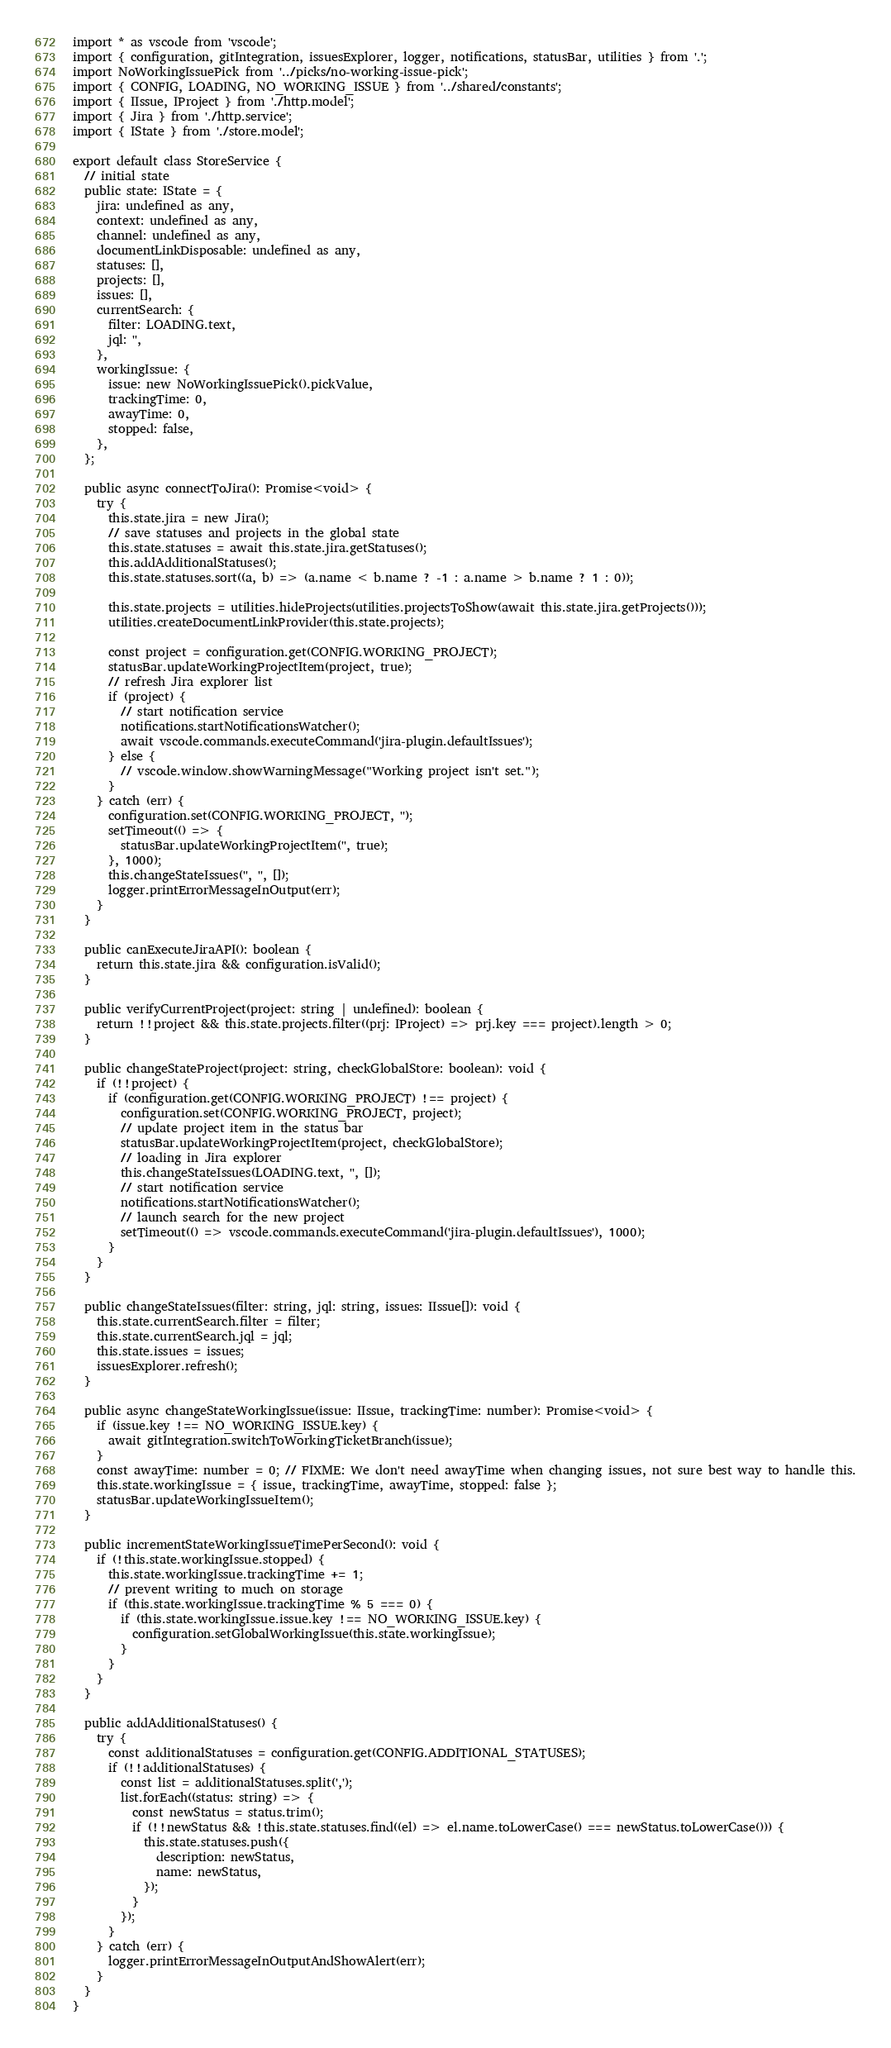Convert code to text. <code><loc_0><loc_0><loc_500><loc_500><_TypeScript_>import * as vscode from 'vscode';
import { configuration, gitIntegration, issuesExplorer, logger, notifications, statusBar, utilities } from '.';
import NoWorkingIssuePick from '../picks/no-working-issue-pick';
import { CONFIG, LOADING, NO_WORKING_ISSUE } from '../shared/constants';
import { IIssue, IProject } from './http.model';
import { Jira } from './http.service';
import { IState } from './store.model';

export default class StoreService {
  // initial state
  public state: IState = {
    jira: undefined as any,
    context: undefined as any,
    channel: undefined as any,
    documentLinkDisposable: undefined as any,
    statuses: [],
    projects: [],
    issues: [],
    currentSearch: {
      filter: LOADING.text,
      jql: '',
    },
    workingIssue: {
      issue: new NoWorkingIssuePick().pickValue,
      trackingTime: 0,
      awayTime: 0,
      stopped: false,
    },
  };

  public async connectToJira(): Promise<void> {
    try {
      this.state.jira = new Jira();
      // save statuses and projects in the global state
      this.state.statuses = await this.state.jira.getStatuses();
      this.addAdditionalStatuses();
      this.state.statuses.sort((a, b) => (a.name < b.name ? -1 : a.name > b.name ? 1 : 0));

      this.state.projects = utilities.hideProjects(utilities.projectsToShow(await this.state.jira.getProjects()));
      utilities.createDocumentLinkProvider(this.state.projects);

      const project = configuration.get(CONFIG.WORKING_PROJECT);
      statusBar.updateWorkingProjectItem(project, true);
      // refresh Jira explorer list
      if (project) {
        // start notification service
        notifications.startNotificationsWatcher();
        await vscode.commands.executeCommand('jira-plugin.defaultIssues');
      } else {
        // vscode.window.showWarningMessage("Working project isn't set.");
      }
    } catch (err) {
      configuration.set(CONFIG.WORKING_PROJECT, '');
      setTimeout(() => {
        statusBar.updateWorkingProjectItem('', true);
      }, 1000);
      this.changeStateIssues('', '', []);
      logger.printErrorMessageInOutput(err);
    }
  }

  public canExecuteJiraAPI(): boolean {
    return this.state.jira && configuration.isValid();
  }

  public verifyCurrentProject(project: string | undefined): boolean {
    return !!project && this.state.projects.filter((prj: IProject) => prj.key === project).length > 0;
  }

  public changeStateProject(project: string, checkGlobalStore: boolean): void {
    if (!!project) {
      if (configuration.get(CONFIG.WORKING_PROJECT) !== project) {
        configuration.set(CONFIG.WORKING_PROJECT, project);
        // update project item in the status bar
        statusBar.updateWorkingProjectItem(project, checkGlobalStore);
        // loading in Jira explorer
        this.changeStateIssues(LOADING.text, '', []);
        // start notification service
        notifications.startNotificationsWatcher();
        // launch search for the new project
        setTimeout(() => vscode.commands.executeCommand('jira-plugin.defaultIssues'), 1000);
      }
    }
  }

  public changeStateIssues(filter: string, jql: string, issues: IIssue[]): void {
    this.state.currentSearch.filter = filter;
    this.state.currentSearch.jql = jql;
    this.state.issues = issues;
    issuesExplorer.refresh();
  }

  public async changeStateWorkingIssue(issue: IIssue, trackingTime: number): Promise<void> {
    if (issue.key !== NO_WORKING_ISSUE.key) {
      await gitIntegration.switchToWorkingTicketBranch(issue);
    }
    const awayTime: number = 0; // FIXME: We don't need awayTime when changing issues, not sure best way to handle this.
    this.state.workingIssue = { issue, trackingTime, awayTime, stopped: false };
    statusBar.updateWorkingIssueItem();
  }

  public incrementStateWorkingIssueTimePerSecond(): void {
    if (!this.state.workingIssue.stopped) {
      this.state.workingIssue.trackingTime += 1;
      // prevent writing to much on storage
      if (this.state.workingIssue.trackingTime % 5 === 0) {
        if (this.state.workingIssue.issue.key !== NO_WORKING_ISSUE.key) {
          configuration.setGlobalWorkingIssue(this.state.workingIssue);
        }
      }
    }
  }

  public addAdditionalStatuses() {
    try {
      const additionalStatuses = configuration.get(CONFIG.ADDITIONAL_STATUSES);
      if (!!additionalStatuses) {
        const list = additionalStatuses.split(',');
        list.forEach((status: string) => {
          const newStatus = status.trim();
          if (!!newStatus && !this.state.statuses.find((el) => el.name.toLowerCase() === newStatus.toLowerCase())) {
            this.state.statuses.push({
              description: newStatus,
              name: newStatus,
            });
          }
        });
      }
    } catch (err) {
      logger.printErrorMessageInOutputAndShowAlert(err);
    }
  }
}
</code> 